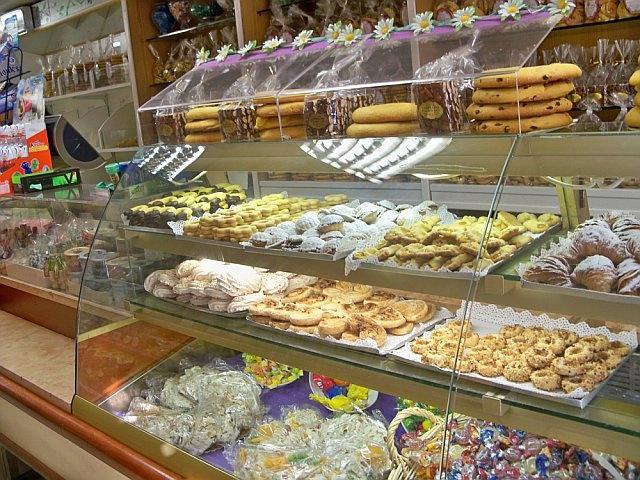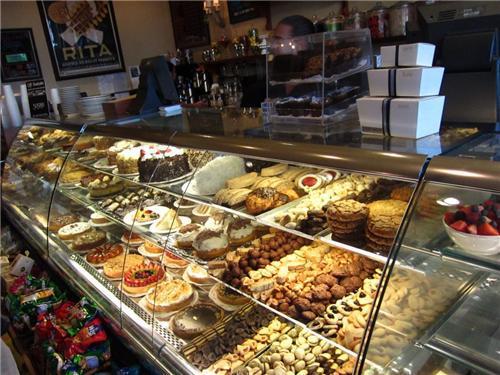The first image is the image on the left, the second image is the image on the right. Given the left and right images, does the statement "In one image, a person is behind a curved, glass-fronted display with white packages on its top." hold true? Answer yes or no. Yes. The first image is the image on the left, the second image is the image on the right. For the images shown, is this caption "Both displays contain three shelves." true? Answer yes or no. Yes. 